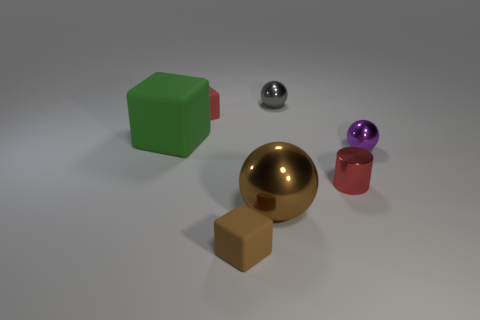Add 3 tiny cyan shiny balls. How many objects exist? 10 Subtract all blocks. How many objects are left? 4 Subtract all yellow metallic blocks. Subtract all green cubes. How many objects are left? 6 Add 4 red matte blocks. How many red matte blocks are left? 5 Add 7 small green shiny balls. How many small green shiny balls exist? 7 Subtract 0 blue spheres. How many objects are left? 7 